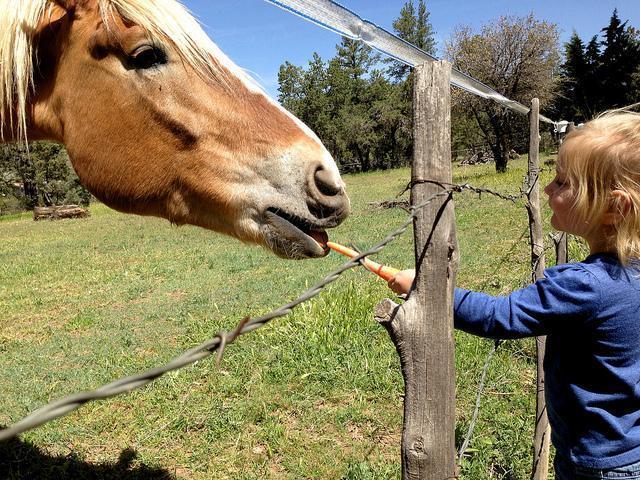How many giraffes are looking away from the camera?
Give a very brief answer. 0. 